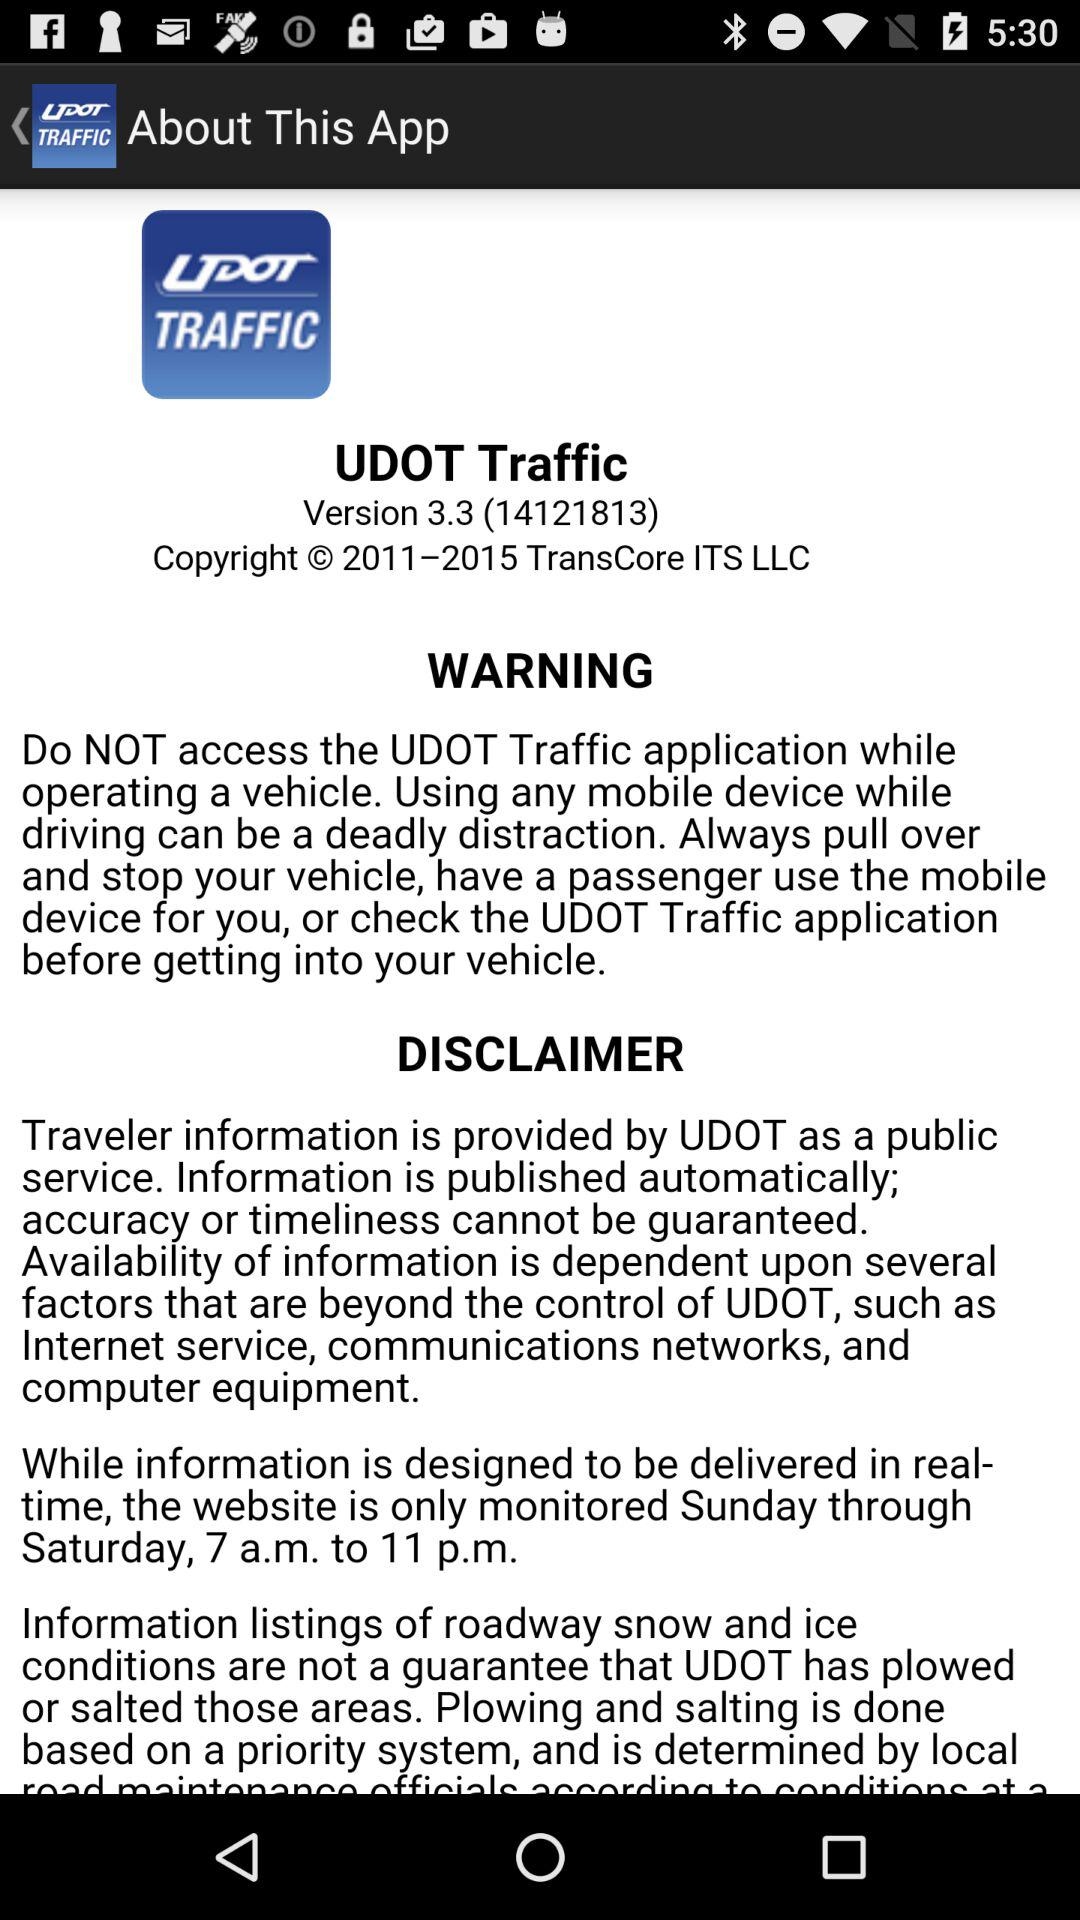What is the duration license?
When the provided information is insufficient, respond with <no answer>. <no answer> 